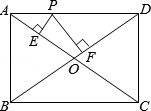First perform reasoning, then finally select the question from the choices in the following format: Answer: xxx.
Question: As shown in the figure, the diagonals AC and BD of rectangle ABCD intersect at point O. Point P is a moving point on side AD. From point P, perpendicular PE is drawn to AC at point E, and perpendicular PF is drawn to BD at point F. If AB = 3 and BC = 4, the value of PE + PF is ().
Choices:
A: 10
B: 9.6
C: 4.8
D: 2.4 Connect OP. Since the two sides of rectangle ABCD, AB = 3 and BC = 4, therefore the area of rectangle ABCD, S = AB2 * BC = 12. OA = OC, OB = OD, AC = BD, AC = √(AB2+BC2) = 5. Therefore, the area of triangle AOD = 0.25 * S of rectangle ABCD = 3. OA = OD = 2.5. Therefore, the area of triangle AOD = area of triangle AOP + area of triangle DOP = 0.5 * OA2 * PE + 0.5 * OD2 * PF = 0.5 * OA * (PE + PF) = 0.5 * 2.5 * (PE + PF) = 3. Therefore, PE + PF = 2.4. Therefore, the correct option is D.
Answer:D 